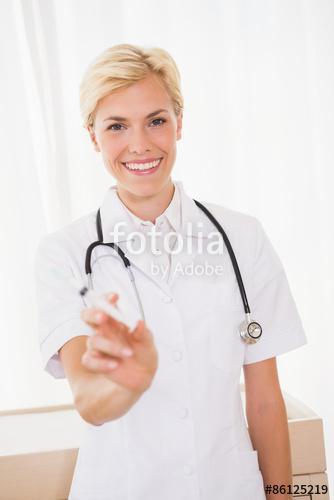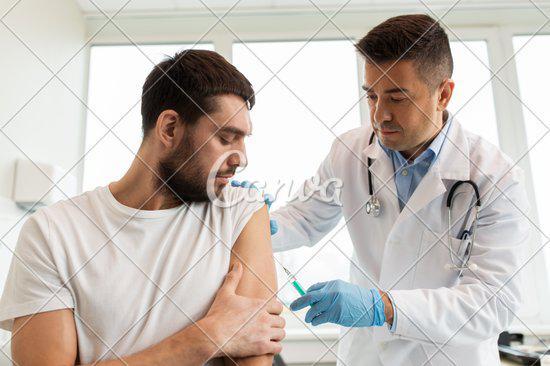The first image is the image on the left, the second image is the image on the right. Assess this claim about the two images: "Two women are holding syringes.". Correct or not? Answer yes or no. No. The first image is the image on the left, the second image is the image on the right. Assess this claim about the two images: "A person is holding a hypdermic needle in a gloved hand in one image.". Correct or not? Answer yes or no. Yes. 